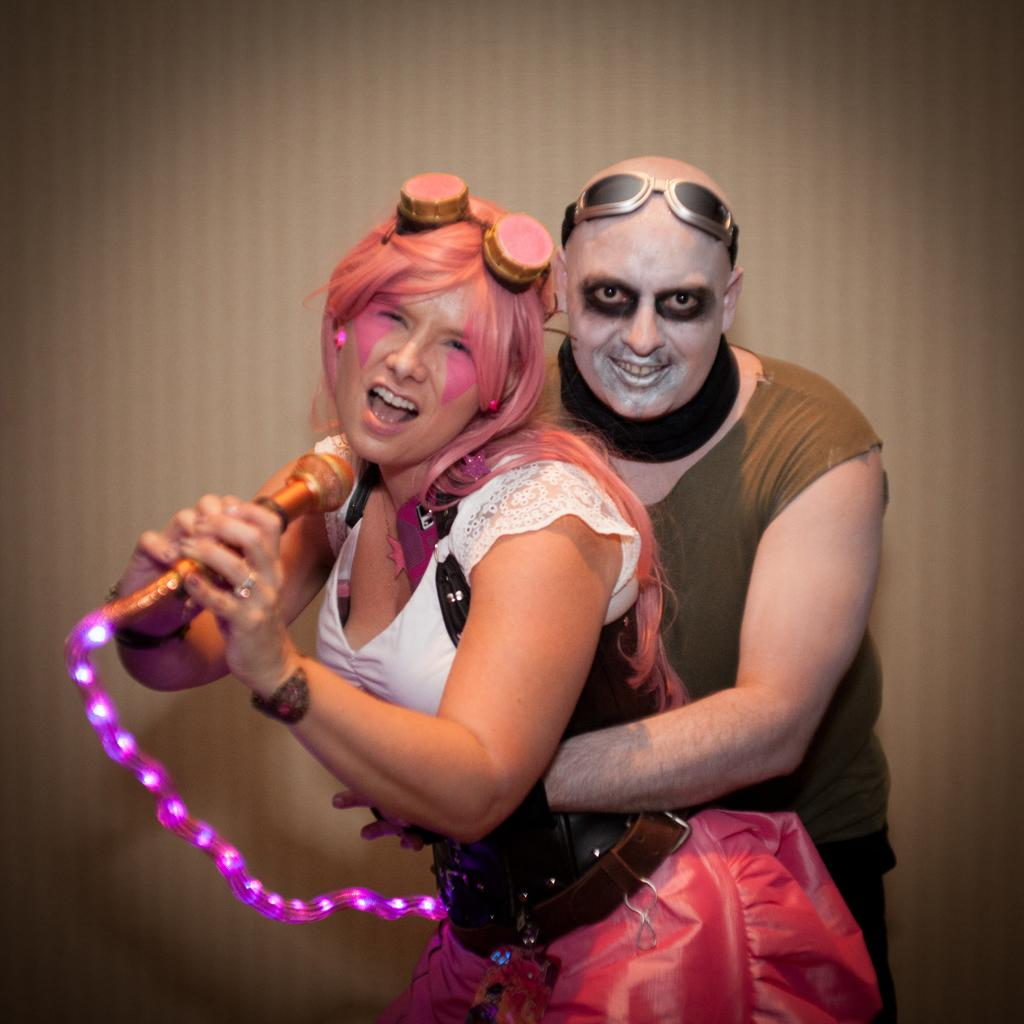What are the people in the image wearing? The people in the image are wearing costumes. Can you describe the person in the foreground? The person in the foreground is holding a microphone. What can be seen in the background of the image? The background of the image is colored. How many toes can be seen on the plane in the image? There is no plane present in the image, and therefore no toes can be seen on a plane. 